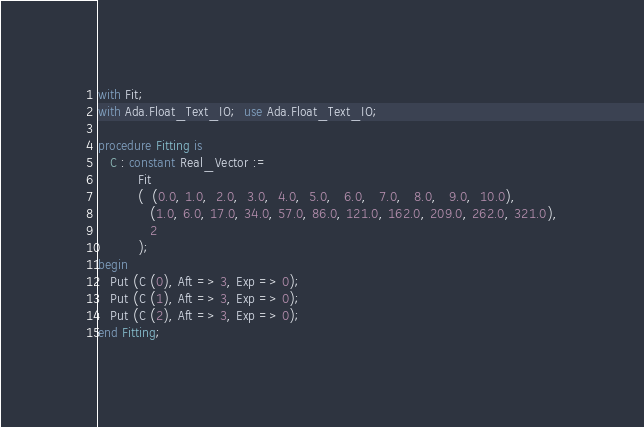<code> <loc_0><loc_0><loc_500><loc_500><_Ada_>with Fit;
with Ada.Float_Text_IO;  use Ada.Float_Text_IO;

procedure Fitting is
   C : constant Real_Vector :=
          Fit
          (  (0.0, 1.0,  2.0,  3.0,  4.0,  5.0,   6.0,   7.0,   8.0,   9.0,  10.0),
             (1.0, 6.0, 17.0, 34.0, 57.0, 86.0, 121.0, 162.0, 209.0, 262.0, 321.0),
             2
          );
begin
   Put (C (0), Aft => 3, Exp => 0);
   Put (C (1), Aft => 3, Exp => 0);
   Put (C (2), Aft => 3, Exp => 0);
end Fitting;
</code> 